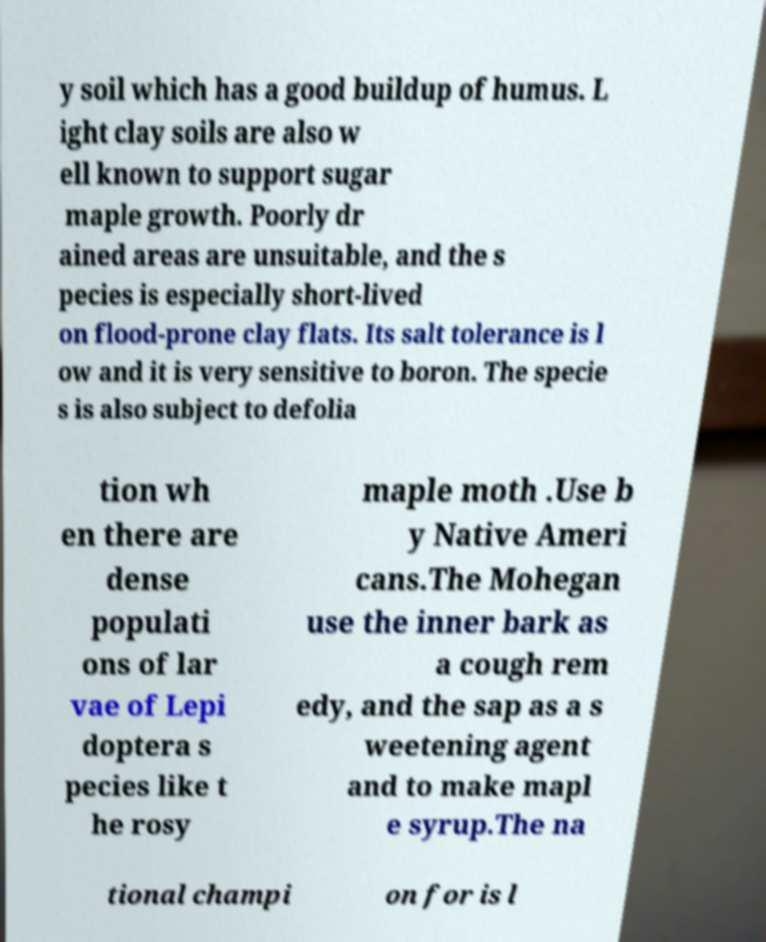Please read and relay the text visible in this image. What does it say? y soil which has a good buildup of humus. L ight clay soils are also w ell known to support sugar maple growth. Poorly dr ained areas are unsuitable, and the s pecies is especially short-lived on flood-prone clay flats. Its salt tolerance is l ow and it is very sensitive to boron. The specie s is also subject to defolia tion wh en there are dense populati ons of lar vae of Lepi doptera s pecies like t he rosy maple moth .Use b y Native Ameri cans.The Mohegan use the inner bark as a cough rem edy, and the sap as a s weetening agent and to make mapl e syrup.The na tional champi on for is l 